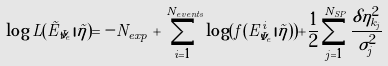<formula> <loc_0><loc_0><loc_500><loc_500>\log L ( \vec { E } _ { \bar { \nu } _ { e } } | \vec { \eta } ) = - N _ { e x p } + \sum _ { i = 1 } ^ { N _ { e v e n t s } } \log ( f ( E ^ { i } _ { \bar { \nu } _ { e } } | \vec { \eta } ) ) + \frac { 1 } { 2 } \sum _ { j = 1 } ^ { N _ { S P } } \frac { \delta \eta ^ { 2 } _ { k _ { j } } } { \sigma ^ { 2 } _ { j } }</formula> 